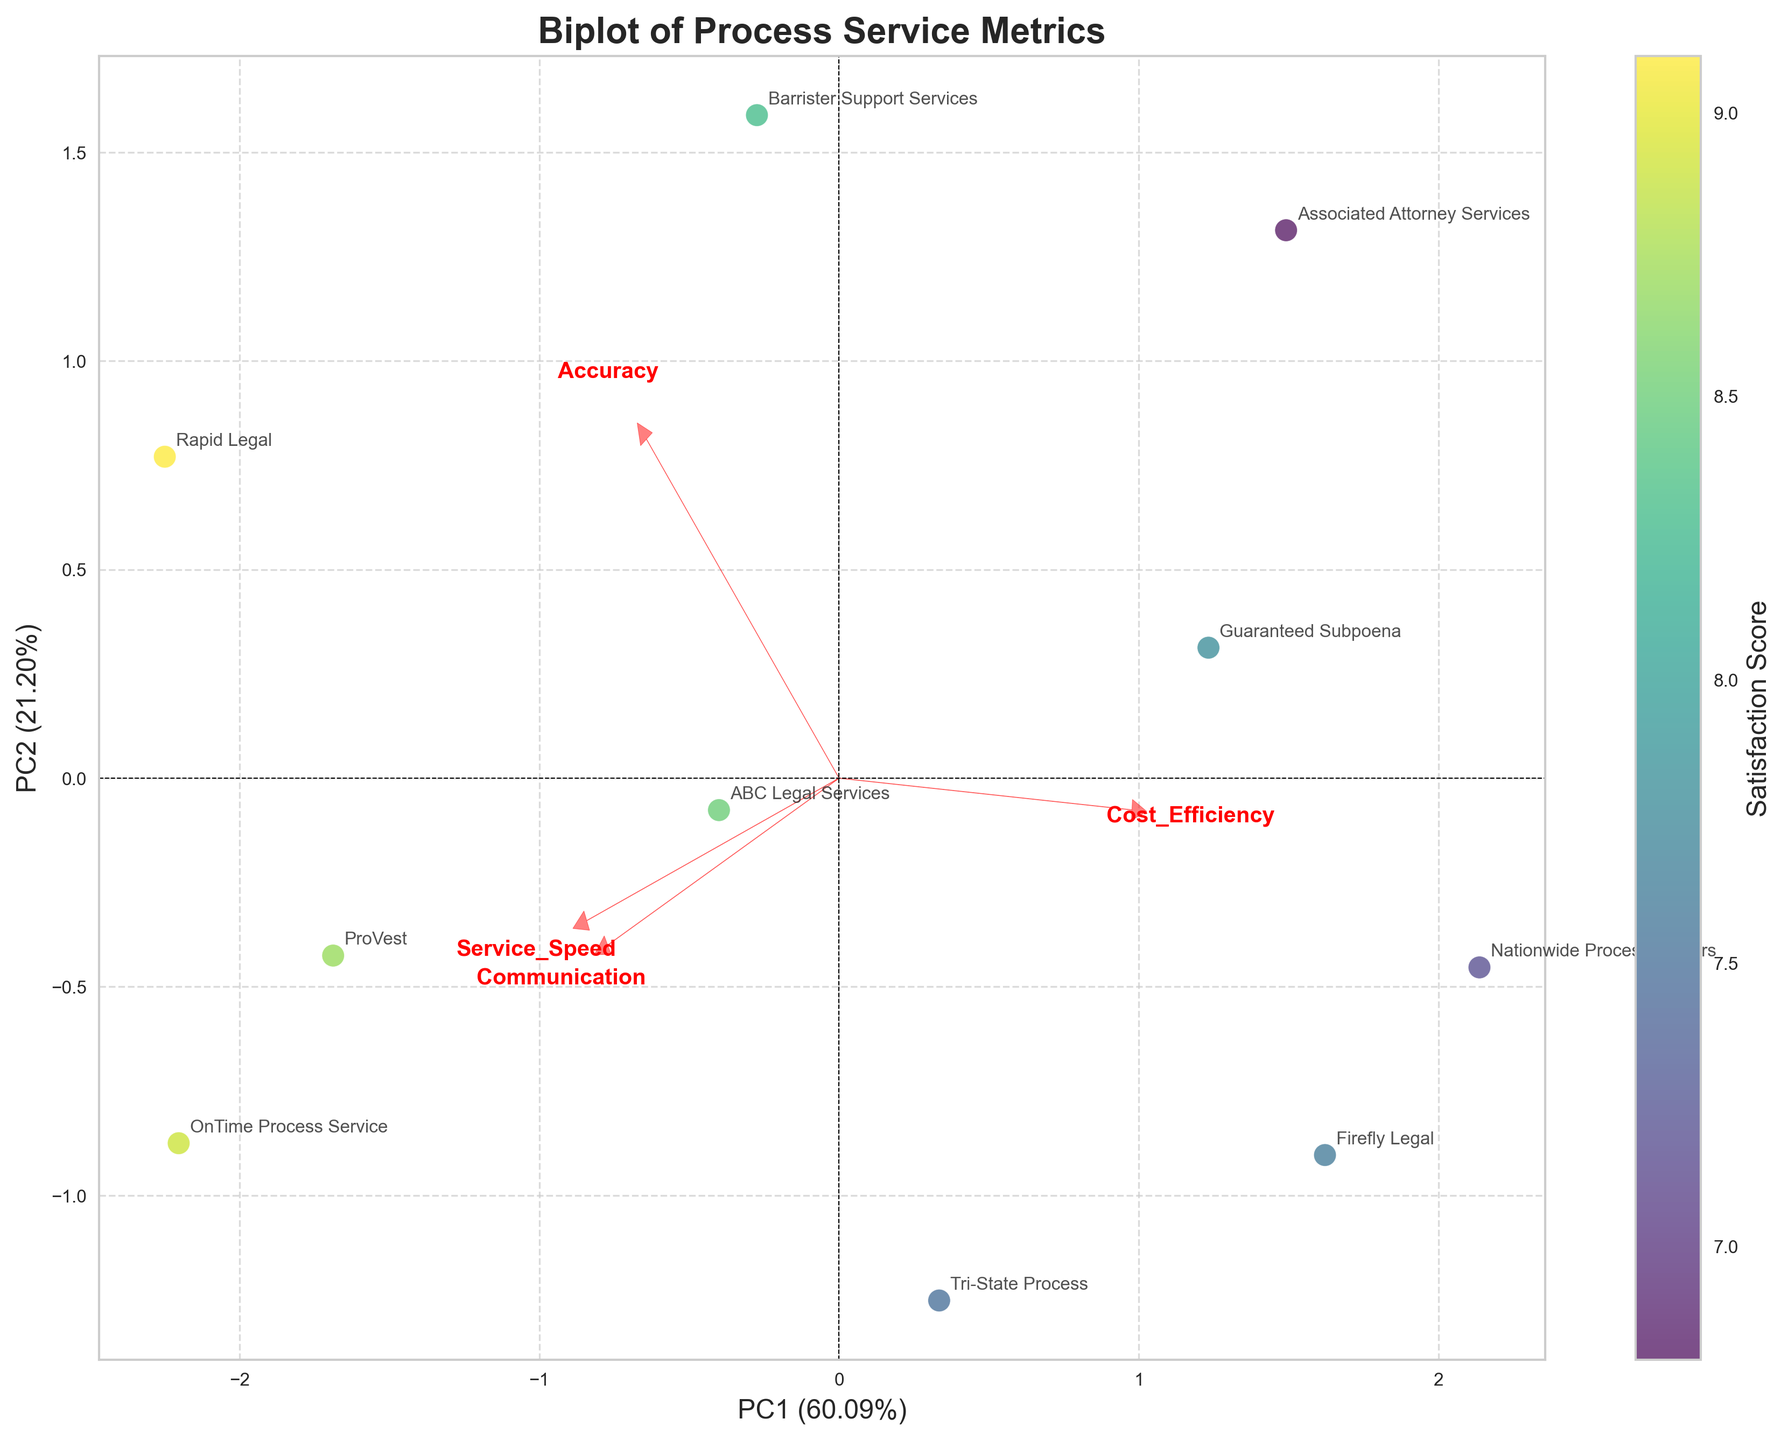How many data points are represented in the plot? To determine the number of data points, you count each individual point plotted on the figure. In this case, each point represents one client.
Answer: 10 What is the title of the plot? The title is located at the top of the plot and describes the main subject of the visualization.
Answer: Biplot of Process Service Metrics Which metric is most strongly correlated with the first principal component (PC1)? This can be determined by examining which arrow has the longest projection along the horizontal axis (PC1).
Answer: Service_Speed Which client has the highest satisfaction score? By looking at the color gradient (which represents satisfaction scores) and the annotations for each client, the client with the most intense color (highest score) can be identified.
Answer: Rapid Legal What's the range of the satisfaction scores in the plot? By looking at the color bar and the spread of satisfaction scores on the plotted points, we find the minimum and maximum values of satisfaction scores in the dataset.
Answer: 6.8 to 9.1 Which principal component explains more variance in the data? This is indicated by the labels of the axes, where the percentage of variance explained by each principal component is provided.
Answer: PC1 Which process server is closest to the origin in the biplot? The proximity to the origin can be gauged by looking at the positions of the points within the plot. You compare their distance to the (0, 0) point on the plot.
Answer: Tri-State Process Which metric appears to have the least influence on either principal component? This is assessed by looking at the lengths of the arrows representing each metric, with the shortest arrow indicating the least influence.
Answer: Cost_Efficiency Is there a clear separation between high and low satisfaction scores in the biplot? By observing the color gradient and distribution of points on the plot, one can see if points with high and low satisfaction scores are clustered separately.
Answer: No Which metrics are positively correlated based on their arrows in the biplot? Positively correlated metrics will have arrows pointing in similar directions. By looking at the directions of the arrows, you can identify pairs.
Answer: Service_Speed and Accuracy 